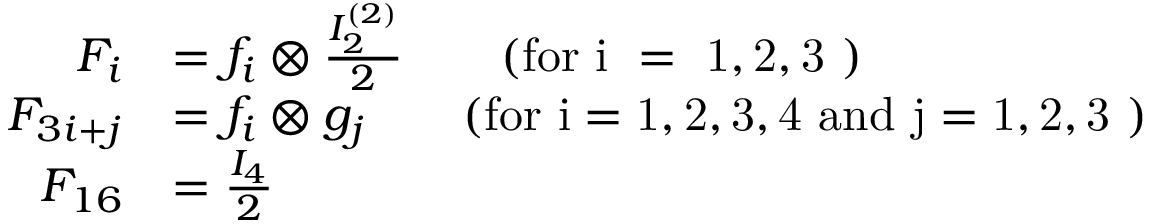Convert formula to latex. <formula><loc_0><loc_0><loc_500><loc_500>\begin{array} { r l } { F _ { i } } & { = f _ { i } \otimes \frac { I _ { 2 } ^ { ( 2 ) } } { 2 } \quad ( f o r i = 1 , 2 , 3 ) } \\ { F _ { 3 i + j } } & { = f _ { i } \otimes g _ { j } \quad ( f o r i = 1 , 2 , 3 , 4 a n d j = 1 , 2 , 3 ) } \\ { F _ { 1 6 } } & { = \frac { I _ { 4 } } { 2 } } \end{array}</formula> 